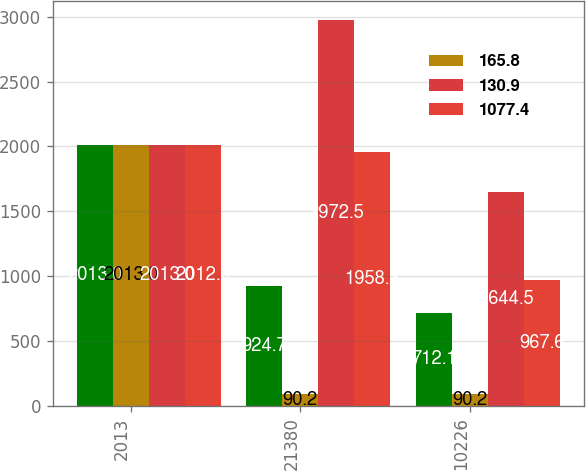<chart> <loc_0><loc_0><loc_500><loc_500><stacked_bar_chart><ecel><fcel>2013<fcel>21380<fcel>10226<nl><fcel>nan<fcel>2013<fcel>924.7<fcel>712.1<nl><fcel>165.8<fcel>2013<fcel>90.2<fcel>90.2<nl><fcel>130.9<fcel>2013<fcel>2972.5<fcel>1644.5<nl><fcel>1077.4<fcel>2012<fcel>1958.3<fcel>967.6<nl></chart> 